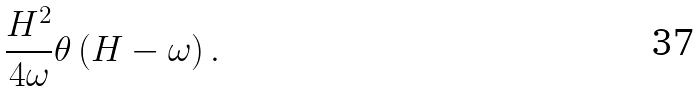<formula> <loc_0><loc_0><loc_500><loc_500>\frac { H ^ { 2 } } { 4 \omega } \theta \left ( H - \omega \right ) .</formula> 